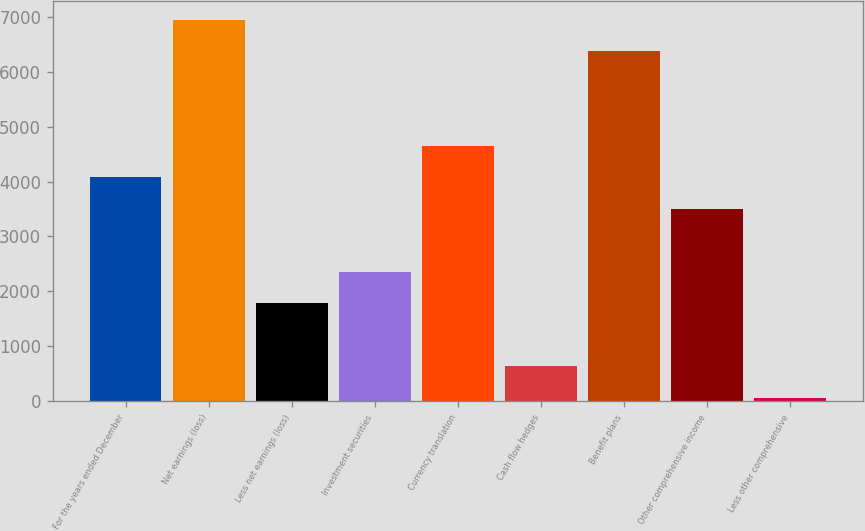<chart> <loc_0><loc_0><loc_500><loc_500><bar_chart><fcel>For the years ended December<fcel>Net earnings (loss)<fcel>Less net earnings (loss)<fcel>Investment securities<fcel>Currency translation<fcel>Cash flow hedges<fcel>Benefit plans<fcel>Other comprehensive income<fcel>Less other comprehensive<nl><fcel>4077.2<fcel>6940.2<fcel>1786.8<fcel>2359.4<fcel>4649.8<fcel>641.6<fcel>6367.6<fcel>3504.6<fcel>69<nl></chart> 